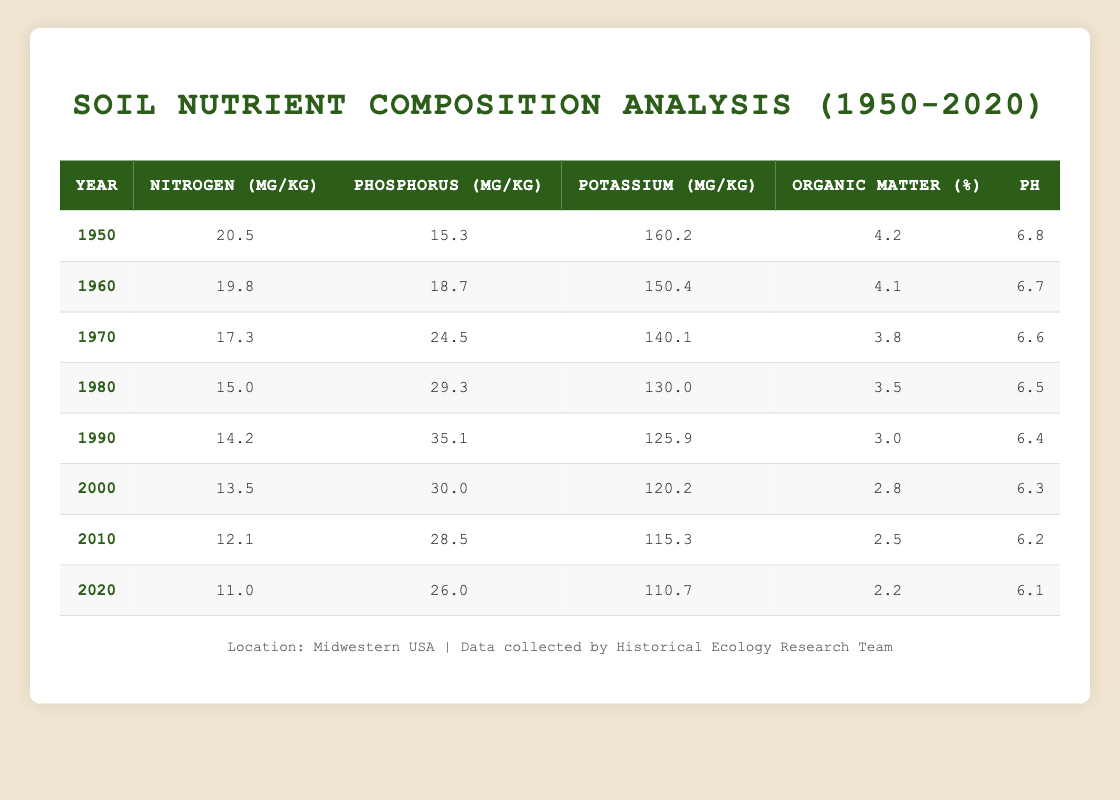What was the nitrogen content in 1970? The nitrogen content for the year 1970 can be found directly in the table under the nitrogen column for that year. It shows a value of 17.3 mg/kg.
Answer: 17.3 mg/kg Which year had the highest phosphorus content? The highest phosphorus content is found in the year with the highest value in the phosphorus column of the table, which is 35.1 mg/kg in 1990.
Answer: 1990 What is the change in potassium content from 1950 to 2020? To find the change in potassium content, we subtract the potassium value for 2020 (110.7 mg/kg) from that of 1950 (160.2 mg/kg). This gives us 160.2 - 110.7 = 49.5 mg/kg decrease.
Answer: 49.5 mg/kg decrease Did the average pH value increase or decrease from 1950 to 2020? The pH values for 1950 and 2020 are 6.8 and 6.1 respectively. Since 6.1 is less than 6.8, it indicates a decrease in pH value over the years.
Answer: Decreased What is the average organic matter percentage from 1950 to 2020? To calculate the average organic matter percentage, add all the organic matter percentages (4.2, 4.1, 3.8, 3.5, 3.0, 2.8, 2.5, 2.2) and divide by the number of data points (8). The sum is 24.1 and the average is 24.1 / 8 = 3.0125, which rounds to approximately 3.01%.
Answer: 3.01% What was the trend in nitrogen content over the decades? By examining the nitrogen values from 1950 to 2020, it's observed that values consistently decrease each decade (20.5, 19.8, 17.3, 15.0, 14.2, 13.5, 12.1, 11.0). This indicates a downward trend in nitrogen content over the decades studied.
Answer: Decreasing trend Was the organic matter percentage ever higher than 4.0%? The organic matter percentages available in the table show values above 4.0% only for the years 1950 (4.2%) and 1960 (4.1%). Thus, it can be concluded that yes, there were years when it was higher than 4.0%.
Answer: Yes Which decade saw the greatest reduction in potassium content? To determine the decade with the greatest reduction in potassium, compare the potassium values at the start of each decade (1950 to 1960, 1960 to 1970, etc.). The largest decrease was from 1950 (160.2 mg/kg) to 1960 (150.4 mg/kg), which is a change of 9.8 mg/kg. This can also be noted as the most significant change across the table.
Answer: 1950-1960 